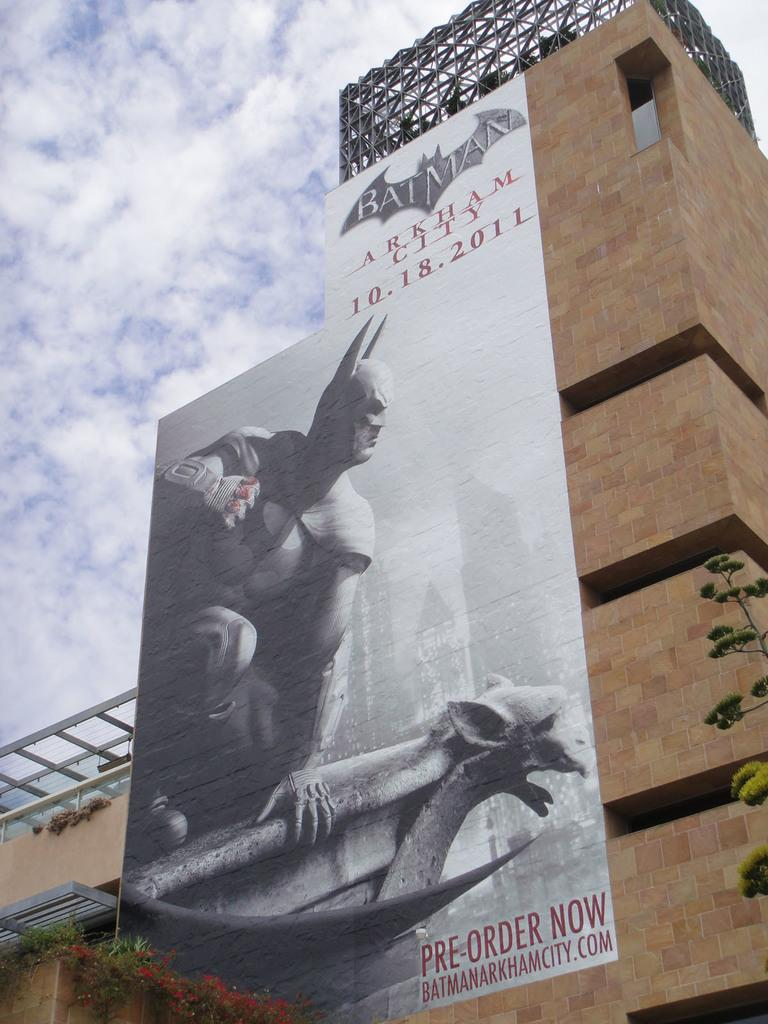Provide a one-sentence caption for the provided image. Pre oder tickets now for the new Batman movie, Gotham City. 